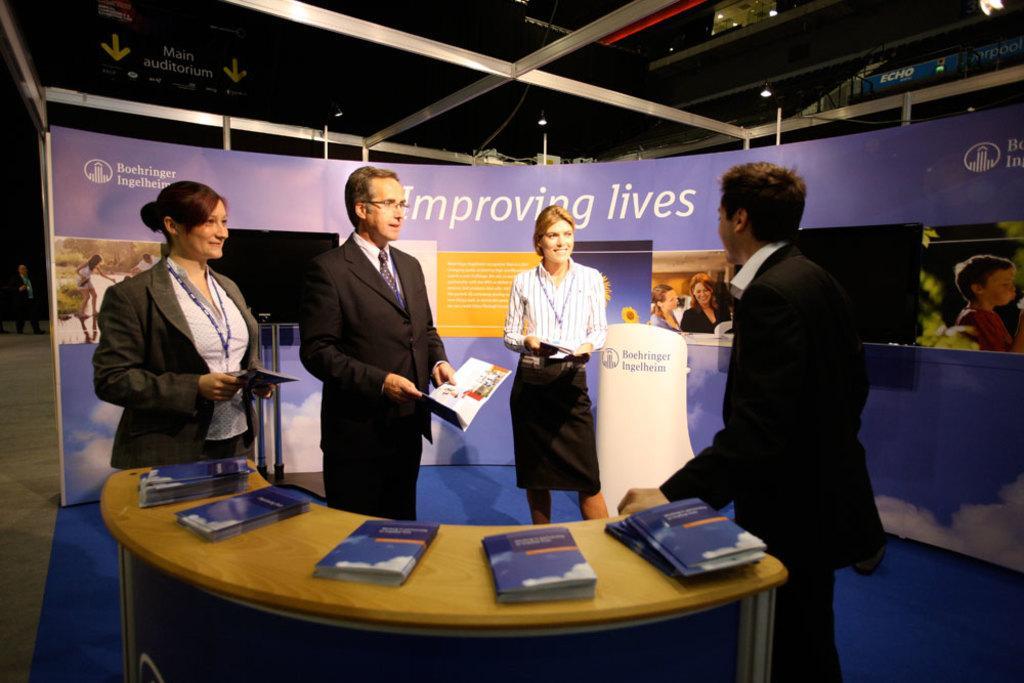Could you give a brief overview of what you see in this image? In the image there are two men suits and two women in skirts standing and holding books, in the front there is table with books on it, in the back there is a banner. 